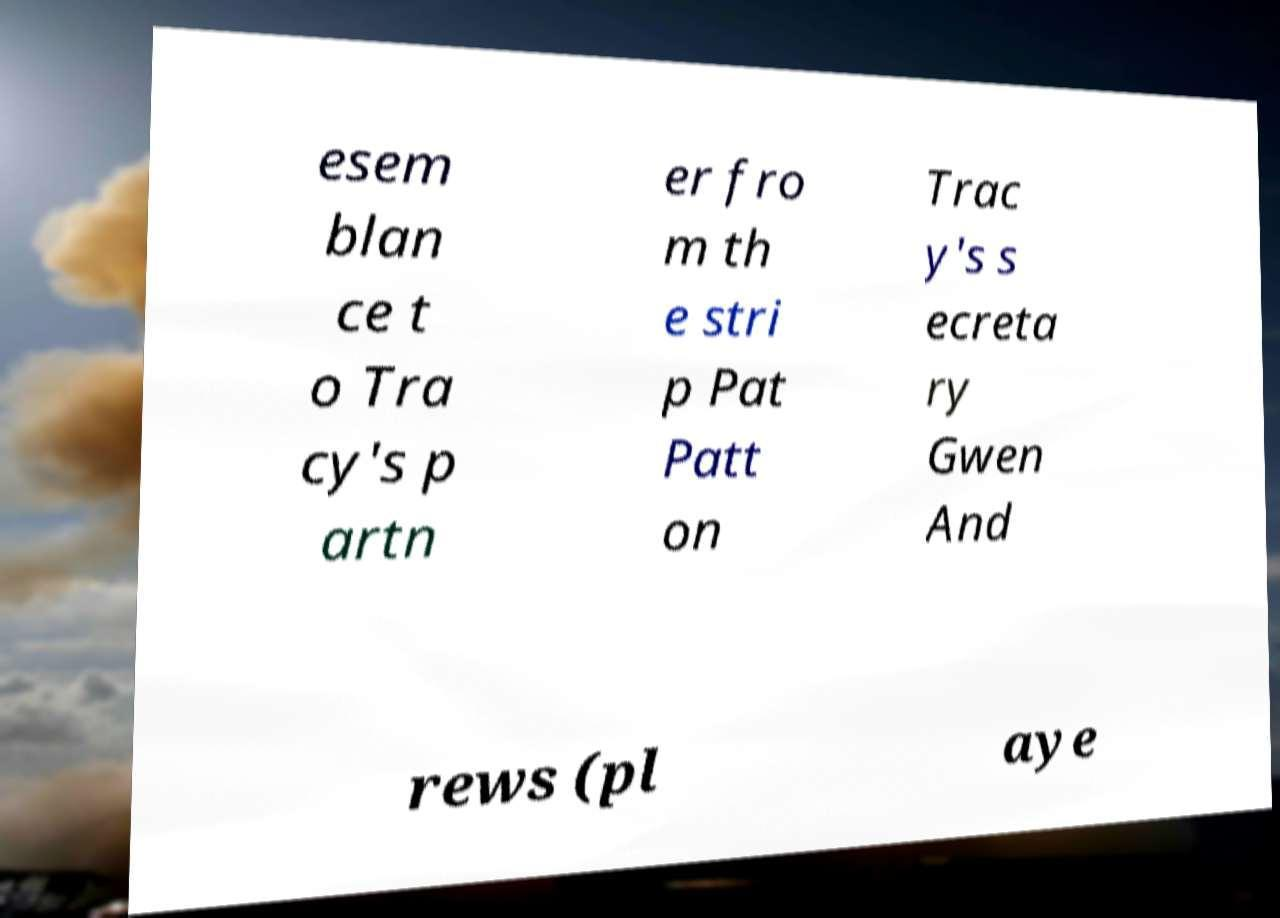I need the written content from this picture converted into text. Can you do that? esem blan ce t o Tra cy's p artn er fro m th e stri p Pat Patt on Trac y's s ecreta ry Gwen And rews (pl aye 